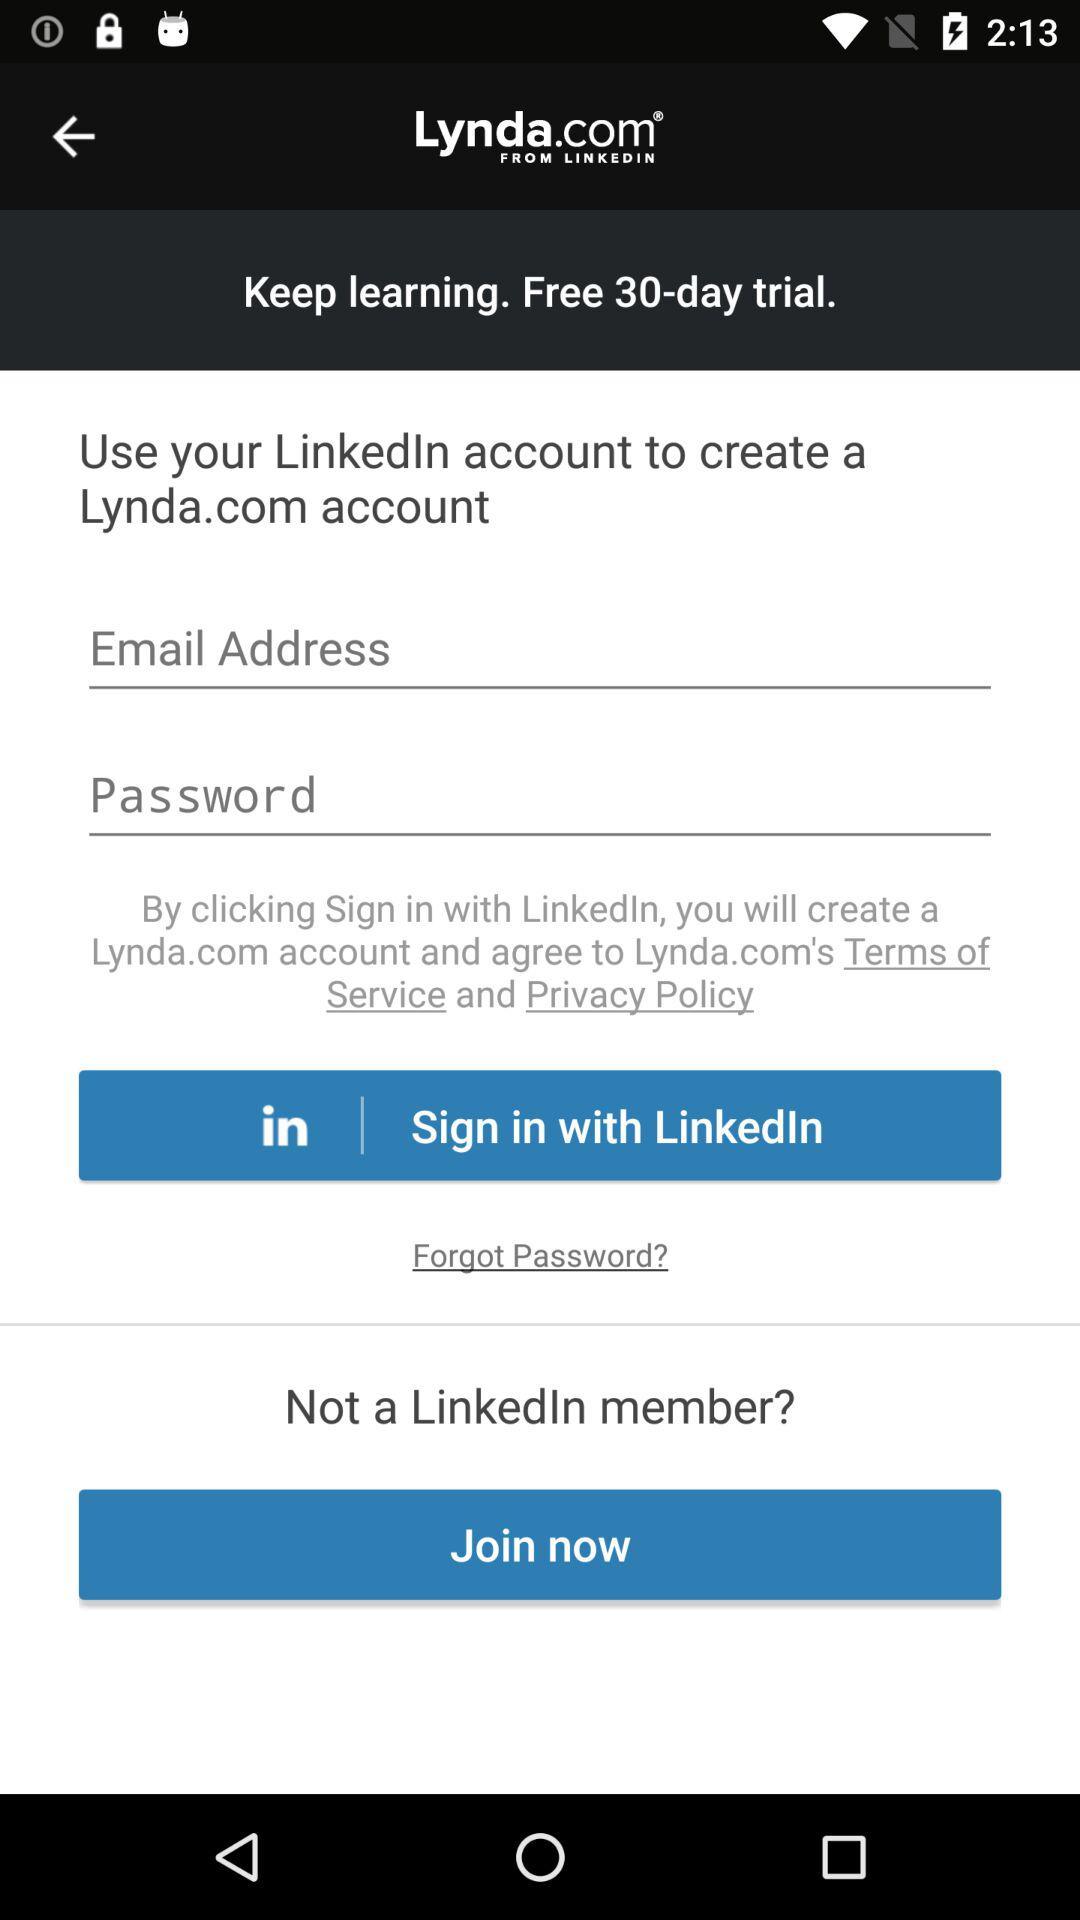How many input fields are there for sign in?
Answer the question using a single word or phrase. 2 